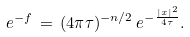<formula> <loc_0><loc_0><loc_500><loc_500>e ^ { - f } \, = \, ( 4 \pi \tau ) ^ { - n / 2 } \, e ^ { - \frac { | x | ^ { 2 } } { 4 \tau } } .</formula> 